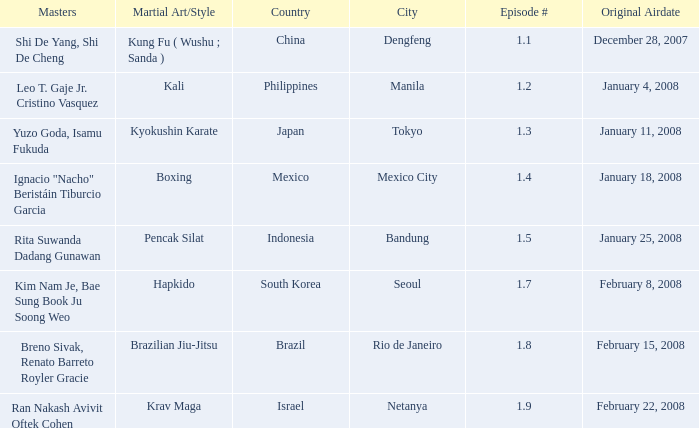How many times did episode 1.8 air? 1.0. 